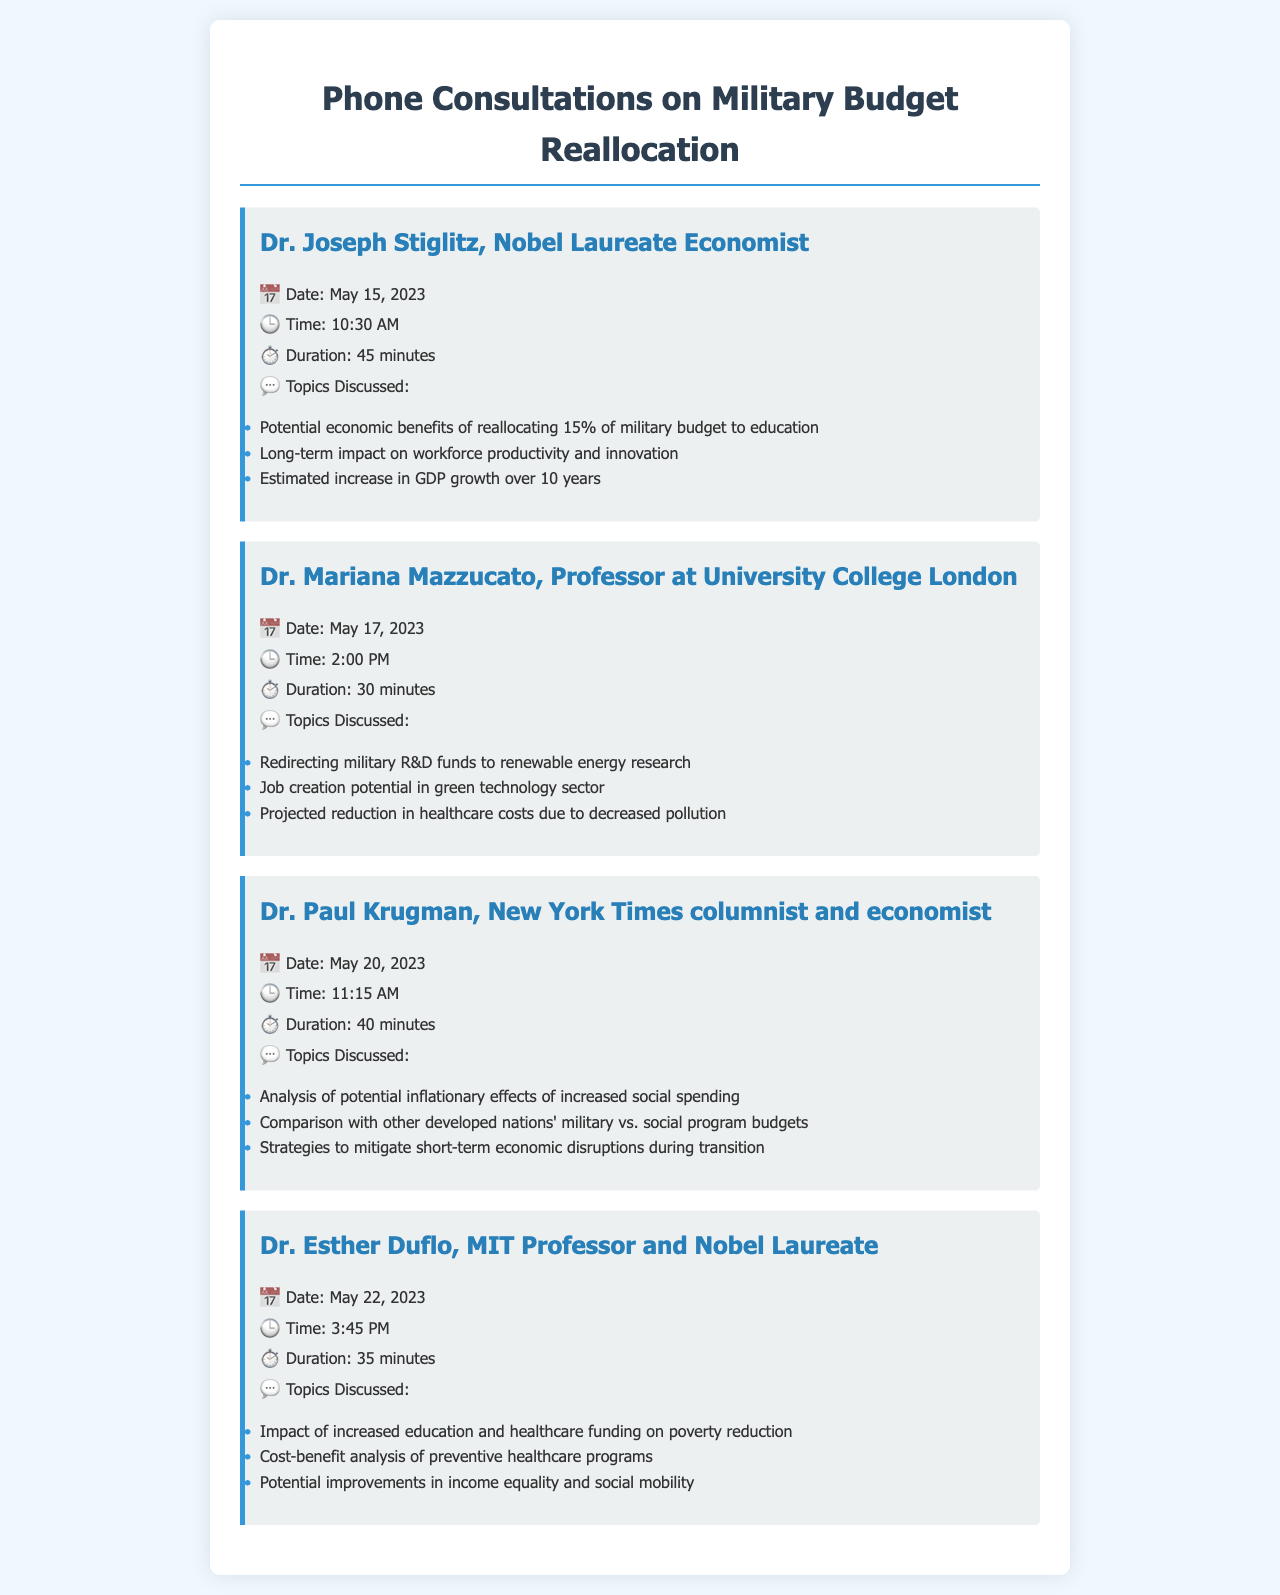What is the date of the consultation with Dr. Joseph Stiglitz? The date of the consultation is specified in the document under Dr. Joseph Stiglitz's record.
Answer: May 15, 2023 How long did the consultation with Dr. Mariana Mazzucato last? The duration of Dr. Mariana Mazzucato's consultation is mentioned in the record.
Answer: 30 minutes What was a key topic discussed with Dr. Paul Krugman? One of the topics discussed with Dr. Paul Krugman is listed in the record.
Answer: Analysis of potential inflationary effects of increased social spending Who is the economist that discussed poverty reduction with the politician? The name of the economist who talked about poverty reduction is in Dr. Esther Duflo's record.
Answer: Dr. Esther Duflo What percentage of the military budget was discussed for reallocation to education? The percentage discussed is found in the topics of Dr. Joseph Stiglitz's consultation.
Answer: 15% Which economist emphasized renewable energy research? The specific economist focused on renewable energy is mentioned in the document.
Answer: Dr. Mariana Mazzucato 